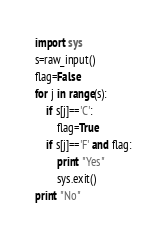Convert code to text. <code><loc_0><loc_0><loc_500><loc_500><_Python_>import sys
s=raw_input()
flag=False
for j in range(s):
    if s[j]=='C':
        flag=True
    if s[j]=='F' and flag:
        print "Yes"
        sys.exit()
print "No"</code> 